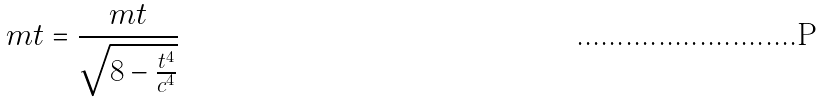<formula> <loc_0><loc_0><loc_500><loc_500>m t = \frac { m t } { \sqrt { 8 - \frac { t ^ { 4 } } { c ^ { 4 } } } }</formula> 